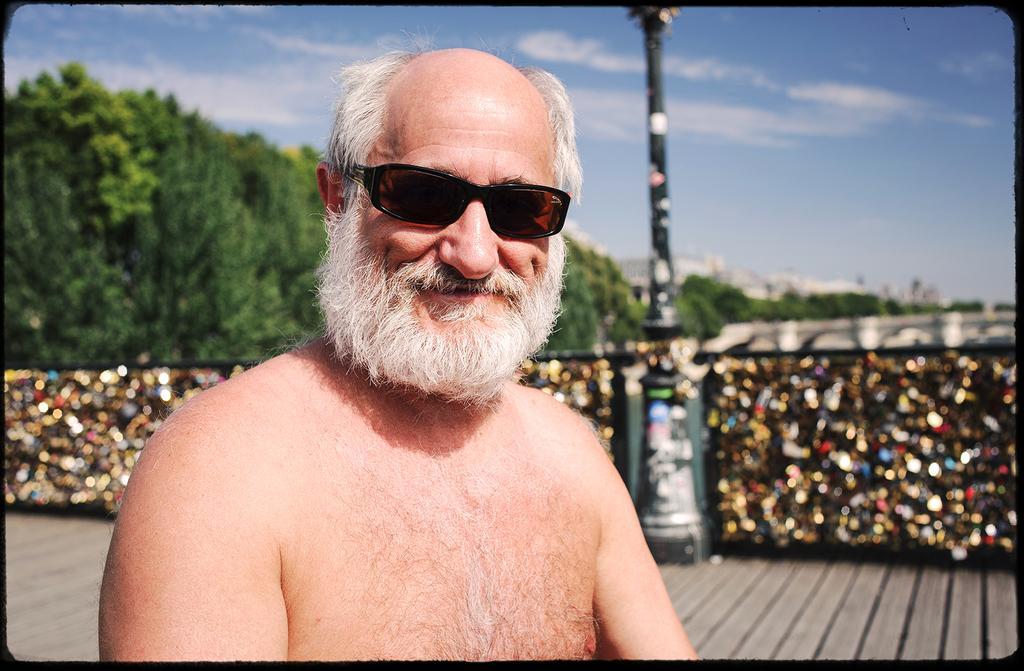Please provide a concise description of this image. In the center of the image we can see person wearing glasses. In the background there are trees, pole, buildings, sky and clouds. 